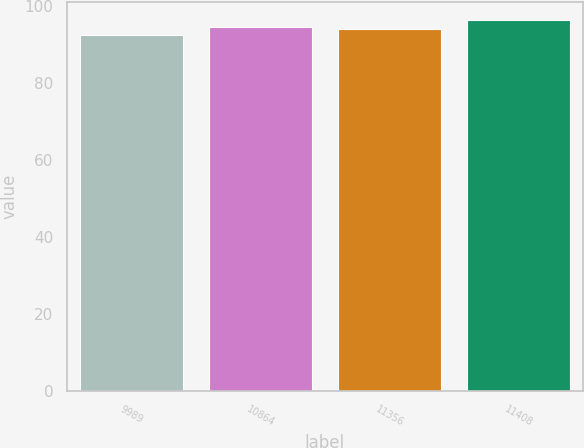Convert chart. <chart><loc_0><loc_0><loc_500><loc_500><bar_chart><fcel>9989<fcel>10864<fcel>11356<fcel>11408<nl><fcel>92.53<fcel>94.49<fcel>94.01<fcel>96.26<nl></chart> 